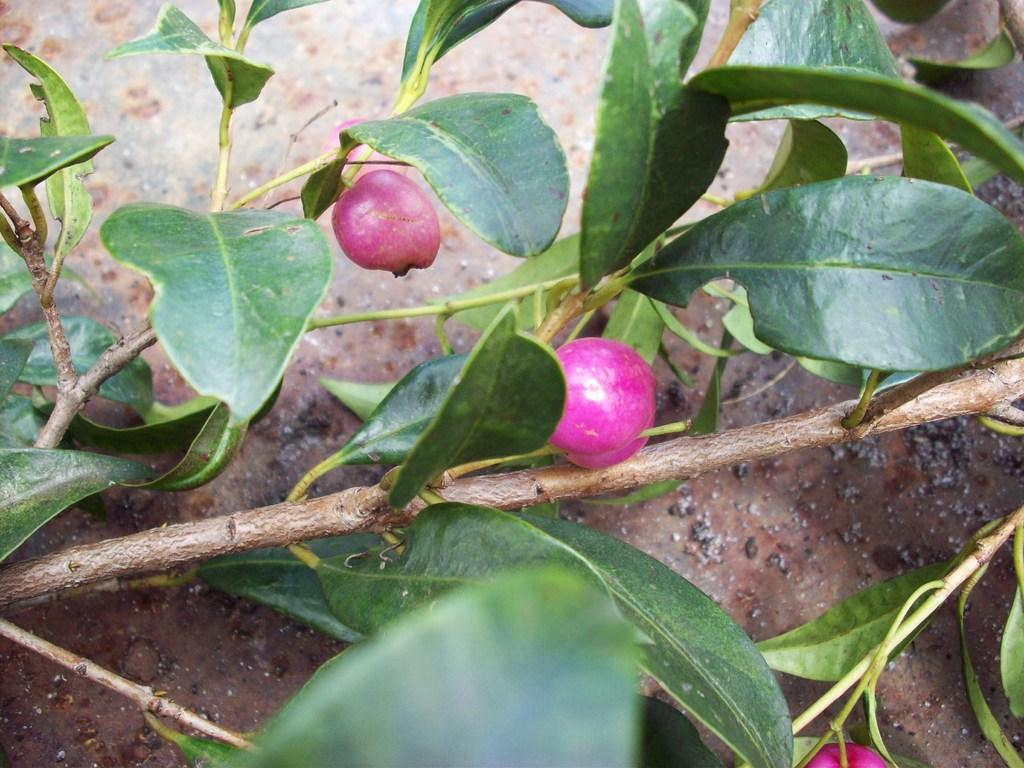What type of food can be seen in the image? There are fruits in the image. How are the fruits connected to the plant? The fruits are attached to the stems of the plant. What type of silver is visible in the image? There is no silver present in the image; it features fruits attached to the stems of a plant. Can you tell me the account balance of the person in the image? There is no person or account balance mentioned in the image; it only shows fruits attached to the stems of a plant. 